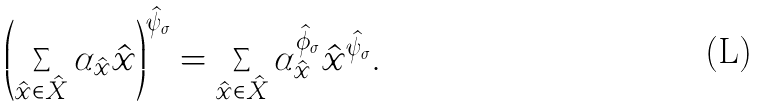Convert formula to latex. <formula><loc_0><loc_0><loc_500><loc_500>\left ( \sum _ { \hat { x } \in \hat { X } } \alpha _ { \hat { x } } \hat { x } \right ) ^ { \hat { \psi } _ { \sigma } } = \sum _ { \hat { x } \in \hat { X } } \alpha _ { \hat { x } } ^ { \hat { \phi } _ { \sigma } } \hat { x } ^ { \hat { \psi } _ { \sigma } } .</formula> 